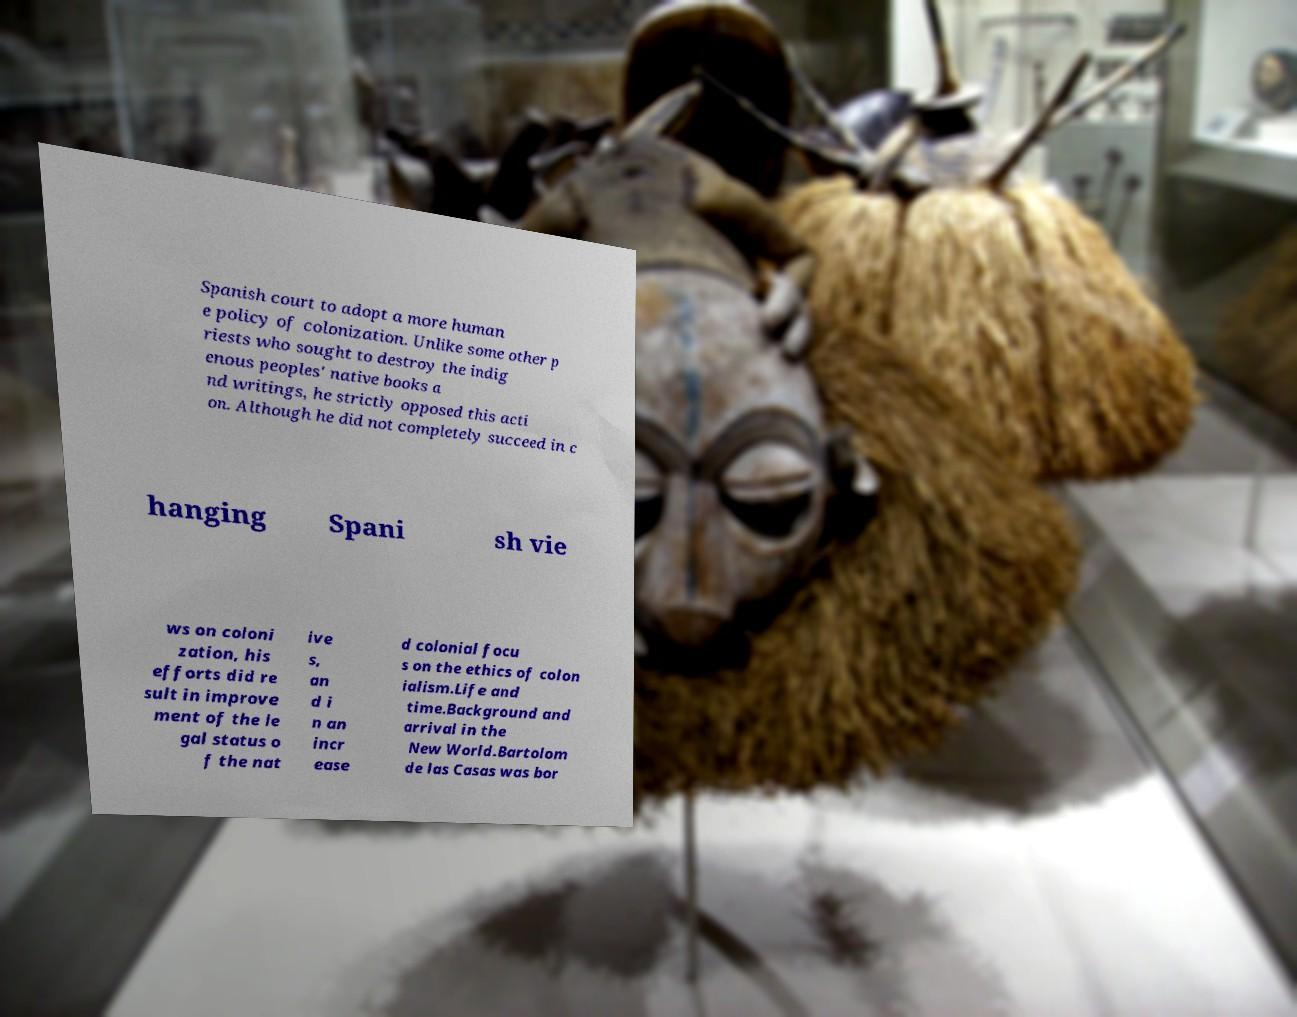Can you read and provide the text displayed in the image?This photo seems to have some interesting text. Can you extract and type it out for me? Spanish court to adopt a more human e policy of colonization. Unlike some other p riests who sought to destroy the indig enous peoples' native books a nd writings, he strictly opposed this acti on. Although he did not completely succeed in c hanging Spani sh vie ws on coloni zation, his efforts did re sult in improve ment of the le gal status o f the nat ive s, an d i n an incr ease d colonial focu s on the ethics of colon ialism.Life and time.Background and arrival in the New World.Bartolom de las Casas was bor 